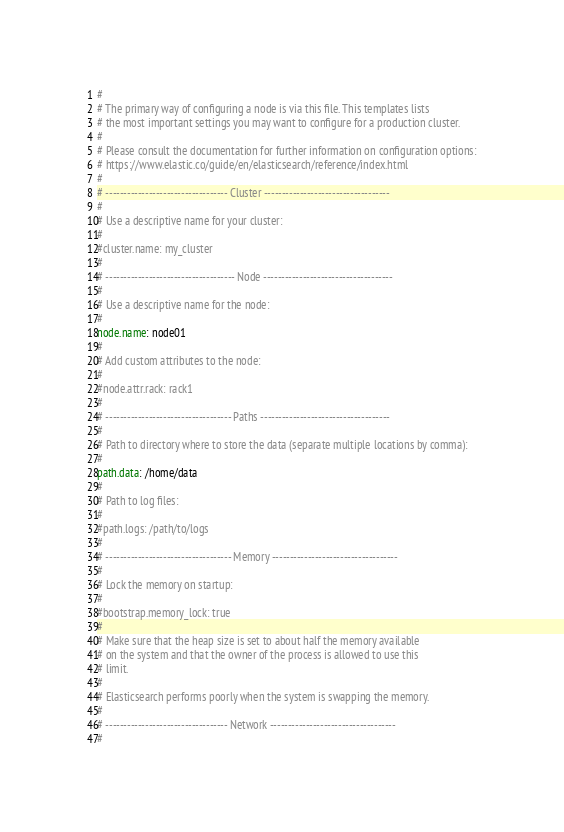<code> <loc_0><loc_0><loc_500><loc_500><_YAML_>#
# The primary way of configuring a node is via this file. This templates lists
# the most important settings you may want to configure for a production cluster.
#
# Please consult the documentation for further information on configuration options:
# https://www.elastic.co/guide/en/elasticsearch/reference/index.html
#
# ---------------------------------- Cluster -----------------------------------
#
# Use a descriptive name for your cluster:
#
#cluster.name: my_cluster
#
# ------------------------------------ Node ------------------------------------
#
# Use a descriptive name for the node:
#
node.name: node01
#
# Add custom attributes to the node:
#
#node.attr.rack: rack1
#
# ----------------------------------- Paths ------------------------------------
#
# Path to directory where to store the data (separate multiple locations by comma):
#
path.data: /home/data
#
# Path to log files:
#
#path.logs: /path/to/logs
#
# ----------------------------------- Memory -----------------------------------
#
# Lock the memory on startup:
#
#bootstrap.memory_lock: true
#
# Make sure that the heap size is set to about half the memory available
# on the system and that the owner of the process is allowed to use this
# limit.
#
# Elasticsearch performs poorly when the system is swapping the memory.
#
# ---------------------------------- Network -----------------------------------
#</code> 